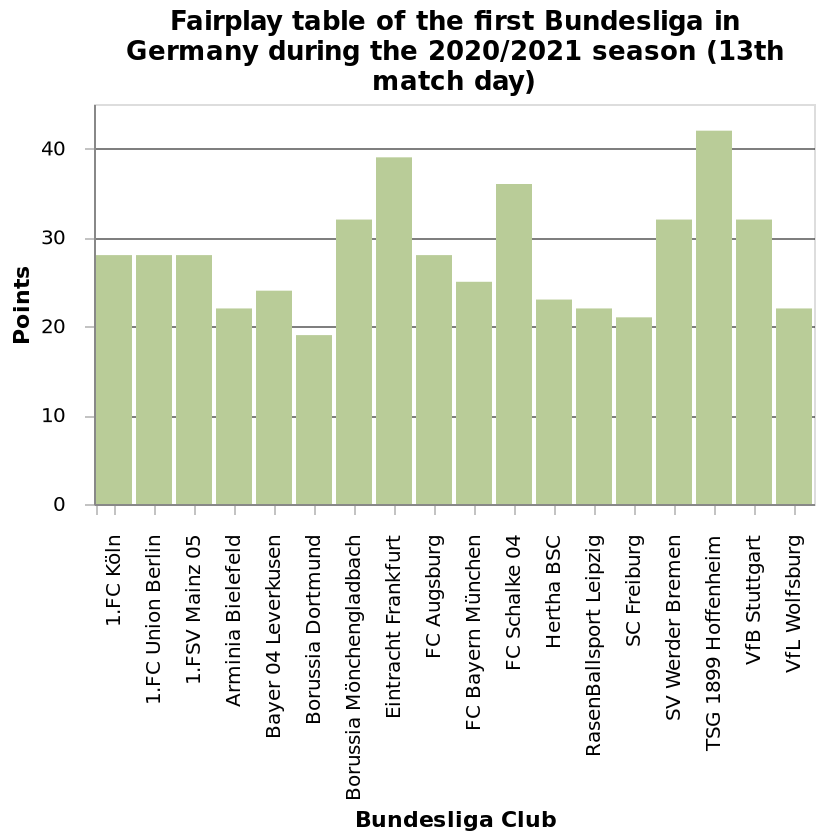<image>
What does the bar diagram represent? The bar diagram represents the points of Bundesliga clubs during the 2020/2021 season (13th match day) in Germany. What is the purpose of the bar diagram? The purpose of the bar diagram is to visually display and compare the points of different Bundesliga clubs in the 2020/2021 season (13th match day) in Germany. Which team had the lowest points? Borussia Dortmund What does the x-axis show in the bar diagram?  The x-axis shows Bundesliga Club in the bar diagram. 